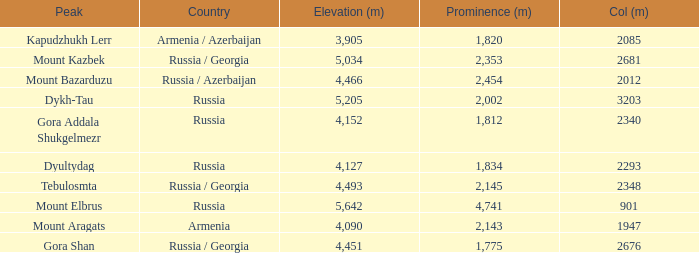With a Col (m) larger than 2012, what is Mount Kazbek's Prominence (m)? 2353.0. 